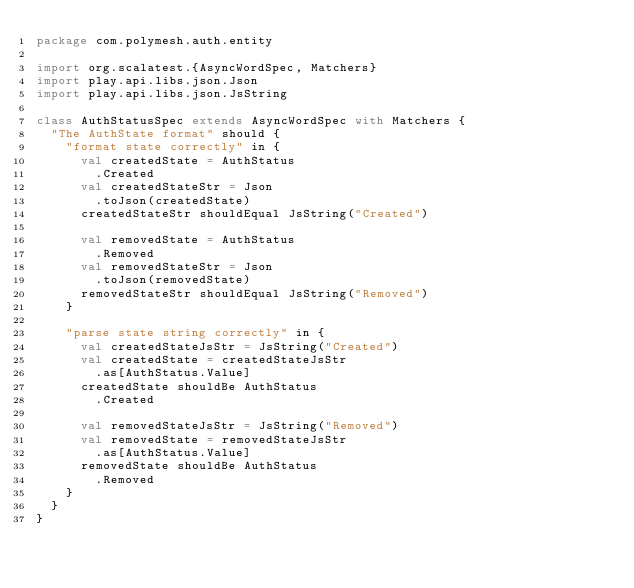Convert code to text. <code><loc_0><loc_0><loc_500><loc_500><_Scala_>package com.polymesh.auth.entity

import org.scalatest.{AsyncWordSpec, Matchers}
import play.api.libs.json.Json
import play.api.libs.json.JsString

class AuthStatusSpec extends AsyncWordSpec with Matchers {
  "The AuthState format" should {
    "format state correctly" in {
      val createdState = AuthStatus
        .Created
      val createdStateStr = Json
        .toJson(createdState)
      createdStateStr shouldEqual JsString("Created")

      val removedState = AuthStatus
        .Removed
      val removedStateStr = Json
        .toJson(removedState)
      removedStateStr shouldEqual JsString("Removed")
    }

    "parse state string correctly" in {
      val createdStateJsStr = JsString("Created")
      val createdState = createdStateJsStr
        .as[AuthStatus.Value]
      createdState shouldBe AuthStatus
        .Created

      val removedStateJsStr = JsString("Removed")
      val removedState = removedStateJsStr
        .as[AuthStatus.Value]
      removedState shouldBe AuthStatus
        .Removed
    }
  }
}
</code> 